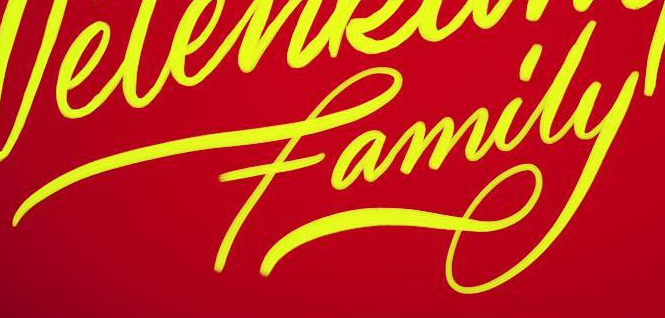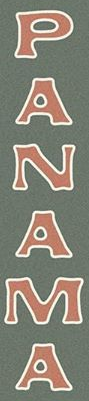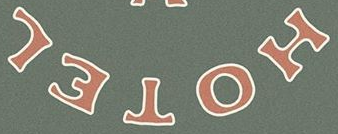What words can you see in these images in sequence, separated by a semicolon? family; PANAMA; HOTEL 